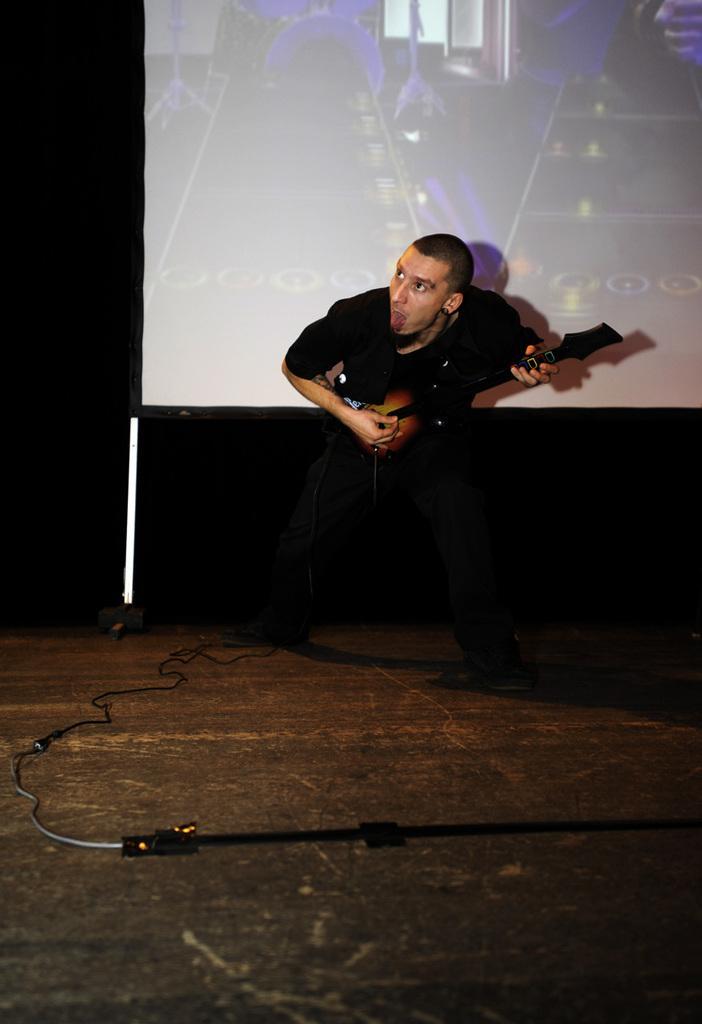Can you describe this image briefly? In this image I see a man who is wearing black shirt and a black jeans and he is holding a guitar in his hand, I can also see a wire over here. In the background I see the screen. 